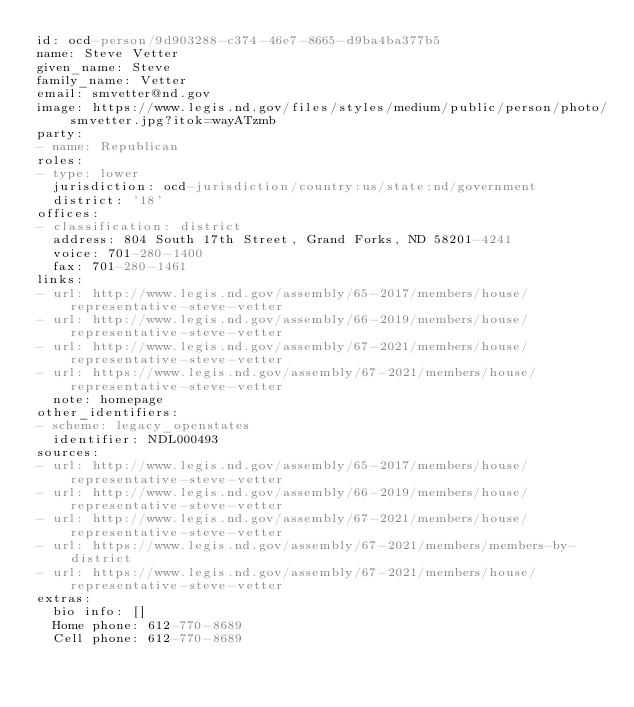Convert code to text. <code><loc_0><loc_0><loc_500><loc_500><_YAML_>id: ocd-person/9d903288-c374-46e7-8665-d9ba4ba377b5
name: Steve Vetter
given_name: Steve
family_name: Vetter
email: smvetter@nd.gov
image: https://www.legis.nd.gov/files/styles/medium/public/person/photo/smvetter.jpg?itok=wayATzmb
party:
- name: Republican
roles:
- type: lower
  jurisdiction: ocd-jurisdiction/country:us/state:nd/government
  district: '18'
offices:
- classification: district
  address: 804 South 17th Street, Grand Forks, ND 58201-4241
  voice: 701-280-1400
  fax: 701-280-1461
links:
- url: http://www.legis.nd.gov/assembly/65-2017/members/house/representative-steve-vetter
- url: http://www.legis.nd.gov/assembly/66-2019/members/house/representative-steve-vetter
- url: http://www.legis.nd.gov/assembly/67-2021/members/house/representative-steve-vetter
- url: https://www.legis.nd.gov/assembly/67-2021/members/house/representative-steve-vetter
  note: homepage
other_identifiers:
- scheme: legacy_openstates
  identifier: NDL000493
sources:
- url: http://www.legis.nd.gov/assembly/65-2017/members/house/representative-steve-vetter
- url: http://www.legis.nd.gov/assembly/66-2019/members/house/representative-steve-vetter
- url: http://www.legis.nd.gov/assembly/67-2021/members/house/representative-steve-vetter
- url: https://www.legis.nd.gov/assembly/67-2021/members/members-by-district
- url: https://www.legis.nd.gov/assembly/67-2021/members/house/representative-steve-vetter
extras:
  bio info: []
  Home phone: 612-770-8689
  Cell phone: 612-770-8689
</code> 